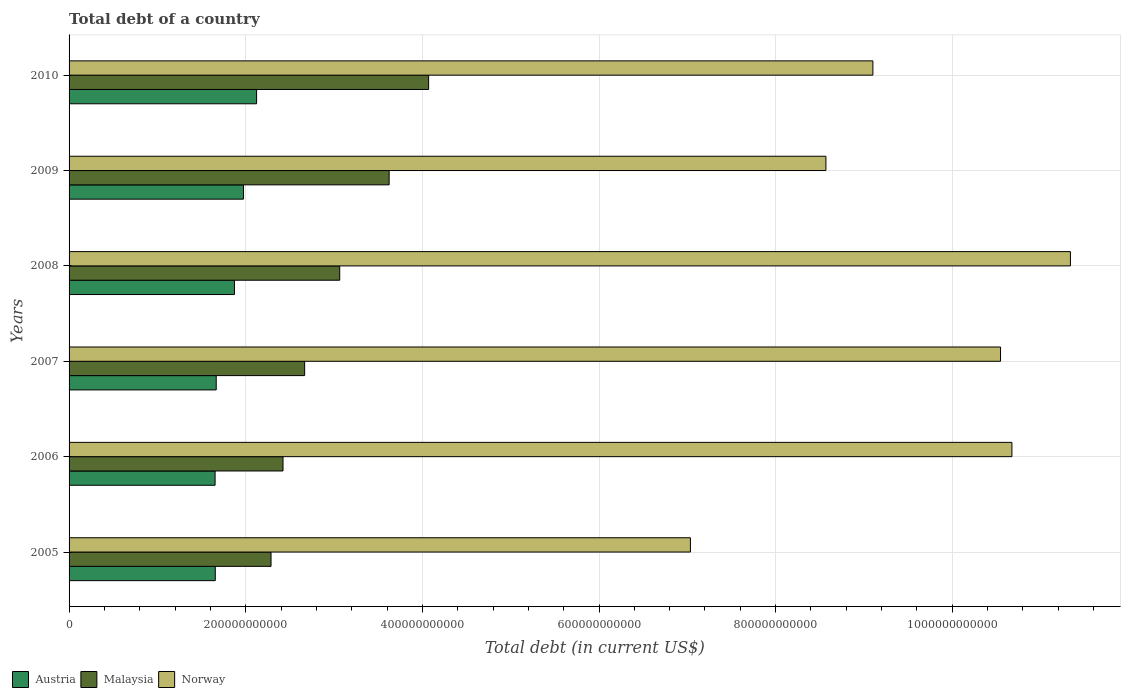How many different coloured bars are there?
Ensure brevity in your answer.  3. How many groups of bars are there?
Keep it short and to the point. 6. Are the number of bars per tick equal to the number of legend labels?
Offer a terse response. Yes. In how many cases, is the number of bars for a given year not equal to the number of legend labels?
Offer a terse response. 0. What is the debt in Norway in 2010?
Provide a succinct answer. 9.10e+11. Across all years, what is the maximum debt in Norway?
Your response must be concise. 1.13e+12. Across all years, what is the minimum debt in Austria?
Provide a short and direct response. 1.65e+11. In which year was the debt in Malaysia maximum?
Your answer should be compact. 2010. What is the total debt in Norway in the graph?
Your answer should be very brief. 5.73e+12. What is the difference between the debt in Malaysia in 2005 and that in 2007?
Offer a terse response. -3.81e+1. What is the difference between the debt in Norway in 2010 and the debt in Malaysia in 2005?
Your answer should be compact. 6.81e+11. What is the average debt in Malaysia per year?
Make the answer very short. 3.02e+11. In the year 2010, what is the difference between the debt in Austria and debt in Malaysia?
Offer a terse response. -1.95e+11. In how many years, is the debt in Malaysia greater than 880000000000 US$?
Keep it short and to the point. 0. What is the ratio of the debt in Malaysia in 2006 to that in 2010?
Your response must be concise. 0.59. What is the difference between the highest and the second highest debt in Malaysia?
Keep it short and to the point. 4.47e+1. What is the difference between the highest and the lowest debt in Austria?
Provide a short and direct response. 4.70e+1. In how many years, is the debt in Norway greater than the average debt in Norway taken over all years?
Provide a short and direct response. 3. Is the sum of the debt in Norway in 2005 and 2009 greater than the maximum debt in Malaysia across all years?
Your answer should be compact. Yes. What does the 1st bar from the top in 2010 represents?
Offer a terse response. Norway. What does the 2nd bar from the bottom in 2008 represents?
Your answer should be compact. Malaysia. Is it the case that in every year, the sum of the debt in Malaysia and debt in Austria is greater than the debt in Norway?
Your answer should be very brief. No. Are all the bars in the graph horizontal?
Ensure brevity in your answer.  Yes. How many years are there in the graph?
Offer a very short reply. 6. What is the difference between two consecutive major ticks on the X-axis?
Keep it short and to the point. 2.00e+11. What is the title of the graph?
Offer a very short reply. Total debt of a country. What is the label or title of the X-axis?
Your response must be concise. Total debt (in current US$). What is the Total debt (in current US$) in Austria in 2005?
Make the answer very short. 1.66e+11. What is the Total debt (in current US$) of Malaysia in 2005?
Your answer should be compact. 2.29e+11. What is the Total debt (in current US$) in Norway in 2005?
Your answer should be very brief. 7.04e+11. What is the Total debt (in current US$) of Austria in 2006?
Your response must be concise. 1.65e+11. What is the Total debt (in current US$) of Malaysia in 2006?
Provide a succinct answer. 2.42e+11. What is the Total debt (in current US$) in Norway in 2006?
Provide a short and direct response. 1.07e+12. What is the Total debt (in current US$) in Austria in 2007?
Give a very brief answer. 1.67e+11. What is the Total debt (in current US$) of Malaysia in 2007?
Your response must be concise. 2.67e+11. What is the Total debt (in current US$) of Norway in 2007?
Offer a very short reply. 1.05e+12. What is the Total debt (in current US$) of Austria in 2008?
Offer a very short reply. 1.87e+11. What is the Total debt (in current US$) of Malaysia in 2008?
Your answer should be compact. 3.06e+11. What is the Total debt (in current US$) of Norway in 2008?
Provide a short and direct response. 1.13e+12. What is the Total debt (in current US$) of Austria in 2009?
Provide a succinct answer. 1.97e+11. What is the Total debt (in current US$) in Malaysia in 2009?
Keep it short and to the point. 3.62e+11. What is the Total debt (in current US$) of Norway in 2009?
Provide a short and direct response. 8.57e+11. What is the Total debt (in current US$) in Austria in 2010?
Offer a terse response. 2.12e+11. What is the Total debt (in current US$) in Malaysia in 2010?
Give a very brief answer. 4.07e+11. What is the Total debt (in current US$) of Norway in 2010?
Ensure brevity in your answer.  9.10e+11. Across all years, what is the maximum Total debt (in current US$) in Austria?
Provide a succinct answer. 2.12e+11. Across all years, what is the maximum Total debt (in current US$) of Malaysia?
Keep it short and to the point. 4.07e+11. Across all years, what is the maximum Total debt (in current US$) in Norway?
Keep it short and to the point. 1.13e+12. Across all years, what is the minimum Total debt (in current US$) in Austria?
Offer a terse response. 1.65e+11. Across all years, what is the minimum Total debt (in current US$) in Malaysia?
Your answer should be very brief. 2.29e+11. Across all years, what is the minimum Total debt (in current US$) in Norway?
Offer a terse response. 7.04e+11. What is the total Total debt (in current US$) of Austria in the graph?
Make the answer very short. 1.09e+12. What is the total Total debt (in current US$) in Malaysia in the graph?
Offer a very short reply. 1.81e+12. What is the total Total debt (in current US$) of Norway in the graph?
Provide a succinct answer. 5.73e+12. What is the difference between the Total debt (in current US$) in Austria in 2005 and that in 2006?
Your response must be concise. 2.14e+08. What is the difference between the Total debt (in current US$) in Malaysia in 2005 and that in 2006?
Give a very brief answer. -1.36e+1. What is the difference between the Total debt (in current US$) in Norway in 2005 and that in 2006?
Your answer should be very brief. -3.64e+11. What is the difference between the Total debt (in current US$) in Austria in 2005 and that in 2007?
Make the answer very short. -1.07e+09. What is the difference between the Total debt (in current US$) in Malaysia in 2005 and that in 2007?
Offer a terse response. -3.81e+1. What is the difference between the Total debt (in current US$) in Norway in 2005 and that in 2007?
Ensure brevity in your answer.  -3.51e+11. What is the difference between the Total debt (in current US$) in Austria in 2005 and that in 2008?
Ensure brevity in your answer.  -2.17e+1. What is the difference between the Total debt (in current US$) in Malaysia in 2005 and that in 2008?
Provide a succinct answer. -7.78e+1. What is the difference between the Total debt (in current US$) in Norway in 2005 and that in 2008?
Keep it short and to the point. -4.30e+11. What is the difference between the Total debt (in current US$) in Austria in 2005 and that in 2009?
Your response must be concise. -3.19e+1. What is the difference between the Total debt (in current US$) in Malaysia in 2005 and that in 2009?
Your response must be concise. -1.34e+11. What is the difference between the Total debt (in current US$) of Norway in 2005 and that in 2009?
Keep it short and to the point. -1.53e+11. What is the difference between the Total debt (in current US$) in Austria in 2005 and that in 2010?
Keep it short and to the point. -4.68e+1. What is the difference between the Total debt (in current US$) of Malaysia in 2005 and that in 2010?
Provide a succinct answer. -1.78e+11. What is the difference between the Total debt (in current US$) of Norway in 2005 and that in 2010?
Your answer should be compact. -2.07e+11. What is the difference between the Total debt (in current US$) of Austria in 2006 and that in 2007?
Keep it short and to the point. -1.28e+09. What is the difference between the Total debt (in current US$) of Malaysia in 2006 and that in 2007?
Your answer should be very brief. -2.45e+1. What is the difference between the Total debt (in current US$) of Norway in 2006 and that in 2007?
Your answer should be compact. 1.29e+1. What is the difference between the Total debt (in current US$) of Austria in 2006 and that in 2008?
Provide a succinct answer. -2.19e+1. What is the difference between the Total debt (in current US$) in Malaysia in 2006 and that in 2008?
Provide a short and direct response. -6.42e+1. What is the difference between the Total debt (in current US$) in Norway in 2006 and that in 2008?
Offer a very short reply. -6.62e+1. What is the difference between the Total debt (in current US$) in Austria in 2006 and that in 2009?
Provide a succinct answer. -3.21e+1. What is the difference between the Total debt (in current US$) in Malaysia in 2006 and that in 2009?
Your answer should be compact. -1.20e+11. What is the difference between the Total debt (in current US$) in Norway in 2006 and that in 2009?
Make the answer very short. 2.11e+11. What is the difference between the Total debt (in current US$) in Austria in 2006 and that in 2010?
Make the answer very short. -4.70e+1. What is the difference between the Total debt (in current US$) of Malaysia in 2006 and that in 2010?
Make the answer very short. -1.65e+11. What is the difference between the Total debt (in current US$) in Norway in 2006 and that in 2010?
Offer a very short reply. 1.57e+11. What is the difference between the Total debt (in current US$) of Austria in 2007 and that in 2008?
Provide a short and direct response. -2.06e+1. What is the difference between the Total debt (in current US$) of Malaysia in 2007 and that in 2008?
Your response must be concise. -3.97e+1. What is the difference between the Total debt (in current US$) of Norway in 2007 and that in 2008?
Ensure brevity in your answer.  -7.91e+1. What is the difference between the Total debt (in current US$) of Austria in 2007 and that in 2009?
Make the answer very short. -3.08e+1. What is the difference between the Total debt (in current US$) in Malaysia in 2007 and that in 2009?
Offer a very short reply. -9.57e+1. What is the difference between the Total debt (in current US$) in Norway in 2007 and that in 2009?
Keep it short and to the point. 1.98e+11. What is the difference between the Total debt (in current US$) in Austria in 2007 and that in 2010?
Provide a succinct answer. -4.57e+1. What is the difference between the Total debt (in current US$) of Malaysia in 2007 and that in 2010?
Your answer should be compact. -1.40e+11. What is the difference between the Total debt (in current US$) in Norway in 2007 and that in 2010?
Provide a short and direct response. 1.45e+11. What is the difference between the Total debt (in current US$) of Austria in 2008 and that in 2009?
Your response must be concise. -1.02e+1. What is the difference between the Total debt (in current US$) of Malaysia in 2008 and that in 2009?
Ensure brevity in your answer.  -5.59e+1. What is the difference between the Total debt (in current US$) in Norway in 2008 and that in 2009?
Make the answer very short. 2.77e+11. What is the difference between the Total debt (in current US$) in Austria in 2008 and that in 2010?
Keep it short and to the point. -2.51e+1. What is the difference between the Total debt (in current US$) in Malaysia in 2008 and that in 2010?
Offer a very short reply. -1.01e+11. What is the difference between the Total debt (in current US$) of Norway in 2008 and that in 2010?
Make the answer very short. 2.24e+11. What is the difference between the Total debt (in current US$) of Austria in 2009 and that in 2010?
Your response must be concise. -1.49e+1. What is the difference between the Total debt (in current US$) in Malaysia in 2009 and that in 2010?
Make the answer very short. -4.47e+1. What is the difference between the Total debt (in current US$) of Norway in 2009 and that in 2010?
Provide a short and direct response. -5.32e+1. What is the difference between the Total debt (in current US$) in Austria in 2005 and the Total debt (in current US$) in Malaysia in 2006?
Your answer should be very brief. -7.67e+1. What is the difference between the Total debt (in current US$) of Austria in 2005 and the Total debt (in current US$) of Norway in 2006?
Offer a very short reply. -9.02e+11. What is the difference between the Total debt (in current US$) of Malaysia in 2005 and the Total debt (in current US$) of Norway in 2006?
Make the answer very short. -8.39e+11. What is the difference between the Total debt (in current US$) in Austria in 2005 and the Total debt (in current US$) in Malaysia in 2007?
Offer a very short reply. -1.01e+11. What is the difference between the Total debt (in current US$) of Austria in 2005 and the Total debt (in current US$) of Norway in 2007?
Provide a short and direct response. -8.89e+11. What is the difference between the Total debt (in current US$) in Malaysia in 2005 and the Total debt (in current US$) in Norway in 2007?
Offer a very short reply. -8.26e+11. What is the difference between the Total debt (in current US$) of Austria in 2005 and the Total debt (in current US$) of Malaysia in 2008?
Keep it short and to the point. -1.41e+11. What is the difference between the Total debt (in current US$) of Austria in 2005 and the Total debt (in current US$) of Norway in 2008?
Provide a succinct answer. -9.68e+11. What is the difference between the Total debt (in current US$) in Malaysia in 2005 and the Total debt (in current US$) in Norway in 2008?
Your answer should be compact. -9.05e+11. What is the difference between the Total debt (in current US$) of Austria in 2005 and the Total debt (in current US$) of Malaysia in 2009?
Offer a terse response. -1.97e+11. What is the difference between the Total debt (in current US$) of Austria in 2005 and the Total debt (in current US$) of Norway in 2009?
Make the answer very short. -6.91e+11. What is the difference between the Total debt (in current US$) of Malaysia in 2005 and the Total debt (in current US$) of Norway in 2009?
Your answer should be very brief. -6.28e+11. What is the difference between the Total debt (in current US$) in Austria in 2005 and the Total debt (in current US$) in Malaysia in 2010?
Your answer should be compact. -2.42e+11. What is the difference between the Total debt (in current US$) in Austria in 2005 and the Total debt (in current US$) in Norway in 2010?
Your answer should be very brief. -7.45e+11. What is the difference between the Total debt (in current US$) in Malaysia in 2005 and the Total debt (in current US$) in Norway in 2010?
Your answer should be compact. -6.81e+11. What is the difference between the Total debt (in current US$) in Austria in 2006 and the Total debt (in current US$) in Malaysia in 2007?
Your answer should be compact. -1.01e+11. What is the difference between the Total debt (in current US$) of Austria in 2006 and the Total debt (in current US$) of Norway in 2007?
Your answer should be compact. -8.89e+11. What is the difference between the Total debt (in current US$) in Malaysia in 2006 and the Total debt (in current US$) in Norway in 2007?
Make the answer very short. -8.12e+11. What is the difference between the Total debt (in current US$) of Austria in 2006 and the Total debt (in current US$) of Malaysia in 2008?
Ensure brevity in your answer.  -1.41e+11. What is the difference between the Total debt (in current US$) in Austria in 2006 and the Total debt (in current US$) in Norway in 2008?
Make the answer very short. -9.68e+11. What is the difference between the Total debt (in current US$) of Malaysia in 2006 and the Total debt (in current US$) of Norway in 2008?
Your answer should be compact. -8.92e+11. What is the difference between the Total debt (in current US$) in Austria in 2006 and the Total debt (in current US$) in Malaysia in 2009?
Give a very brief answer. -1.97e+11. What is the difference between the Total debt (in current US$) of Austria in 2006 and the Total debt (in current US$) of Norway in 2009?
Keep it short and to the point. -6.92e+11. What is the difference between the Total debt (in current US$) of Malaysia in 2006 and the Total debt (in current US$) of Norway in 2009?
Offer a very short reply. -6.15e+11. What is the difference between the Total debt (in current US$) of Austria in 2006 and the Total debt (in current US$) of Malaysia in 2010?
Give a very brief answer. -2.42e+11. What is the difference between the Total debt (in current US$) of Austria in 2006 and the Total debt (in current US$) of Norway in 2010?
Your answer should be compact. -7.45e+11. What is the difference between the Total debt (in current US$) in Malaysia in 2006 and the Total debt (in current US$) in Norway in 2010?
Make the answer very short. -6.68e+11. What is the difference between the Total debt (in current US$) in Austria in 2007 and the Total debt (in current US$) in Malaysia in 2008?
Give a very brief answer. -1.40e+11. What is the difference between the Total debt (in current US$) in Austria in 2007 and the Total debt (in current US$) in Norway in 2008?
Give a very brief answer. -9.67e+11. What is the difference between the Total debt (in current US$) of Malaysia in 2007 and the Total debt (in current US$) of Norway in 2008?
Give a very brief answer. -8.67e+11. What is the difference between the Total debt (in current US$) in Austria in 2007 and the Total debt (in current US$) in Malaysia in 2009?
Provide a short and direct response. -1.96e+11. What is the difference between the Total debt (in current US$) in Austria in 2007 and the Total debt (in current US$) in Norway in 2009?
Offer a terse response. -6.90e+11. What is the difference between the Total debt (in current US$) of Malaysia in 2007 and the Total debt (in current US$) of Norway in 2009?
Ensure brevity in your answer.  -5.90e+11. What is the difference between the Total debt (in current US$) in Austria in 2007 and the Total debt (in current US$) in Malaysia in 2010?
Ensure brevity in your answer.  -2.40e+11. What is the difference between the Total debt (in current US$) of Austria in 2007 and the Total debt (in current US$) of Norway in 2010?
Offer a very short reply. -7.43e+11. What is the difference between the Total debt (in current US$) of Malaysia in 2007 and the Total debt (in current US$) of Norway in 2010?
Provide a short and direct response. -6.43e+11. What is the difference between the Total debt (in current US$) in Austria in 2008 and the Total debt (in current US$) in Malaysia in 2009?
Offer a very short reply. -1.75e+11. What is the difference between the Total debt (in current US$) of Austria in 2008 and the Total debt (in current US$) of Norway in 2009?
Your answer should be very brief. -6.70e+11. What is the difference between the Total debt (in current US$) of Malaysia in 2008 and the Total debt (in current US$) of Norway in 2009?
Make the answer very short. -5.50e+11. What is the difference between the Total debt (in current US$) of Austria in 2008 and the Total debt (in current US$) of Malaysia in 2010?
Ensure brevity in your answer.  -2.20e+11. What is the difference between the Total debt (in current US$) in Austria in 2008 and the Total debt (in current US$) in Norway in 2010?
Provide a short and direct response. -7.23e+11. What is the difference between the Total debt (in current US$) in Malaysia in 2008 and the Total debt (in current US$) in Norway in 2010?
Your answer should be very brief. -6.04e+11. What is the difference between the Total debt (in current US$) in Austria in 2009 and the Total debt (in current US$) in Malaysia in 2010?
Offer a very short reply. -2.10e+11. What is the difference between the Total debt (in current US$) in Austria in 2009 and the Total debt (in current US$) in Norway in 2010?
Offer a very short reply. -7.13e+11. What is the difference between the Total debt (in current US$) of Malaysia in 2009 and the Total debt (in current US$) of Norway in 2010?
Your response must be concise. -5.48e+11. What is the average Total debt (in current US$) in Austria per year?
Ensure brevity in your answer.  1.82e+11. What is the average Total debt (in current US$) in Malaysia per year?
Your answer should be very brief. 3.02e+11. What is the average Total debt (in current US$) of Norway per year?
Your answer should be compact. 9.54e+11. In the year 2005, what is the difference between the Total debt (in current US$) of Austria and Total debt (in current US$) of Malaysia?
Make the answer very short. -6.31e+1. In the year 2005, what is the difference between the Total debt (in current US$) in Austria and Total debt (in current US$) in Norway?
Offer a terse response. -5.38e+11. In the year 2005, what is the difference between the Total debt (in current US$) in Malaysia and Total debt (in current US$) in Norway?
Make the answer very short. -4.75e+11. In the year 2006, what is the difference between the Total debt (in current US$) of Austria and Total debt (in current US$) of Malaysia?
Make the answer very short. -7.69e+1. In the year 2006, what is the difference between the Total debt (in current US$) of Austria and Total debt (in current US$) of Norway?
Make the answer very short. -9.02e+11. In the year 2006, what is the difference between the Total debt (in current US$) in Malaysia and Total debt (in current US$) in Norway?
Offer a terse response. -8.25e+11. In the year 2007, what is the difference between the Total debt (in current US$) of Austria and Total debt (in current US$) of Malaysia?
Give a very brief answer. -1.00e+11. In the year 2007, what is the difference between the Total debt (in current US$) of Austria and Total debt (in current US$) of Norway?
Your response must be concise. -8.88e+11. In the year 2007, what is the difference between the Total debt (in current US$) in Malaysia and Total debt (in current US$) in Norway?
Offer a very short reply. -7.88e+11. In the year 2008, what is the difference between the Total debt (in current US$) of Austria and Total debt (in current US$) of Malaysia?
Give a very brief answer. -1.19e+11. In the year 2008, what is the difference between the Total debt (in current US$) in Austria and Total debt (in current US$) in Norway?
Ensure brevity in your answer.  -9.46e+11. In the year 2008, what is the difference between the Total debt (in current US$) of Malaysia and Total debt (in current US$) of Norway?
Offer a very short reply. -8.27e+11. In the year 2009, what is the difference between the Total debt (in current US$) in Austria and Total debt (in current US$) in Malaysia?
Provide a succinct answer. -1.65e+11. In the year 2009, what is the difference between the Total debt (in current US$) of Austria and Total debt (in current US$) of Norway?
Provide a succinct answer. -6.59e+11. In the year 2009, what is the difference between the Total debt (in current US$) in Malaysia and Total debt (in current US$) in Norway?
Make the answer very short. -4.95e+11. In the year 2010, what is the difference between the Total debt (in current US$) in Austria and Total debt (in current US$) in Malaysia?
Give a very brief answer. -1.95e+11. In the year 2010, what is the difference between the Total debt (in current US$) in Austria and Total debt (in current US$) in Norway?
Your response must be concise. -6.98e+11. In the year 2010, what is the difference between the Total debt (in current US$) of Malaysia and Total debt (in current US$) of Norway?
Give a very brief answer. -5.03e+11. What is the ratio of the Total debt (in current US$) in Malaysia in 2005 to that in 2006?
Provide a succinct answer. 0.94. What is the ratio of the Total debt (in current US$) of Norway in 2005 to that in 2006?
Ensure brevity in your answer.  0.66. What is the ratio of the Total debt (in current US$) in Malaysia in 2005 to that in 2007?
Ensure brevity in your answer.  0.86. What is the ratio of the Total debt (in current US$) in Norway in 2005 to that in 2007?
Offer a very short reply. 0.67. What is the ratio of the Total debt (in current US$) in Austria in 2005 to that in 2008?
Provide a short and direct response. 0.88. What is the ratio of the Total debt (in current US$) of Malaysia in 2005 to that in 2008?
Your answer should be compact. 0.75. What is the ratio of the Total debt (in current US$) of Norway in 2005 to that in 2008?
Offer a terse response. 0.62. What is the ratio of the Total debt (in current US$) of Austria in 2005 to that in 2009?
Make the answer very short. 0.84. What is the ratio of the Total debt (in current US$) in Malaysia in 2005 to that in 2009?
Your answer should be very brief. 0.63. What is the ratio of the Total debt (in current US$) in Norway in 2005 to that in 2009?
Give a very brief answer. 0.82. What is the ratio of the Total debt (in current US$) in Austria in 2005 to that in 2010?
Offer a very short reply. 0.78. What is the ratio of the Total debt (in current US$) of Malaysia in 2005 to that in 2010?
Your answer should be compact. 0.56. What is the ratio of the Total debt (in current US$) in Norway in 2005 to that in 2010?
Your response must be concise. 0.77. What is the ratio of the Total debt (in current US$) of Austria in 2006 to that in 2007?
Your answer should be compact. 0.99. What is the ratio of the Total debt (in current US$) of Malaysia in 2006 to that in 2007?
Keep it short and to the point. 0.91. What is the ratio of the Total debt (in current US$) in Norway in 2006 to that in 2007?
Offer a terse response. 1.01. What is the ratio of the Total debt (in current US$) of Austria in 2006 to that in 2008?
Provide a succinct answer. 0.88. What is the ratio of the Total debt (in current US$) in Malaysia in 2006 to that in 2008?
Your response must be concise. 0.79. What is the ratio of the Total debt (in current US$) in Norway in 2006 to that in 2008?
Offer a very short reply. 0.94. What is the ratio of the Total debt (in current US$) of Austria in 2006 to that in 2009?
Ensure brevity in your answer.  0.84. What is the ratio of the Total debt (in current US$) of Malaysia in 2006 to that in 2009?
Your answer should be compact. 0.67. What is the ratio of the Total debt (in current US$) of Norway in 2006 to that in 2009?
Your answer should be very brief. 1.25. What is the ratio of the Total debt (in current US$) in Austria in 2006 to that in 2010?
Your answer should be very brief. 0.78. What is the ratio of the Total debt (in current US$) in Malaysia in 2006 to that in 2010?
Provide a short and direct response. 0.59. What is the ratio of the Total debt (in current US$) in Norway in 2006 to that in 2010?
Make the answer very short. 1.17. What is the ratio of the Total debt (in current US$) in Austria in 2007 to that in 2008?
Your response must be concise. 0.89. What is the ratio of the Total debt (in current US$) in Malaysia in 2007 to that in 2008?
Keep it short and to the point. 0.87. What is the ratio of the Total debt (in current US$) of Norway in 2007 to that in 2008?
Your response must be concise. 0.93. What is the ratio of the Total debt (in current US$) in Austria in 2007 to that in 2009?
Provide a short and direct response. 0.84. What is the ratio of the Total debt (in current US$) in Malaysia in 2007 to that in 2009?
Your response must be concise. 0.74. What is the ratio of the Total debt (in current US$) in Norway in 2007 to that in 2009?
Offer a terse response. 1.23. What is the ratio of the Total debt (in current US$) in Austria in 2007 to that in 2010?
Your answer should be compact. 0.78. What is the ratio of the Total debt (in current US$) of Malaysia in 2007 to that in 2010?
Give a very brief answer. 0.66. What is the ratio of the Total debt (in current US$) of Norway in 2007 to that in 2010?
Provide a short and direct response. 1.16. What is the ratio of the Total debt (in current US$) in Austria in 2008 to that in 2009?
Keep it short and to the point. 0.95. What is the ratio of the Total debt (in current US$) of Malaysia in 2008 to that in 2009?
Give a very brief answer. 0.85. What is the ratio of the Total debt (in current US$) in Norway in 2008 to that in 2009?
Give a very brief answer. 1.32. What is the ratio of the Total debt (in current US$) of Austria in 2008 to that in 2010?
Keep it short and to the point. 0.88. What is the ratio of the Total debt (in current US$) in Malaysia in 2008 to that in 2010?
Keep it short and to the point. 0.75. What is the ratio of the Total debt (in current US$) of Norway in 2008 to that in 2010?
Your answer should be very brief. 1.25. What is the ratio of the Total debt (in current US$) in Malaysia in 2009 to that in 2010?
Your response must be concise. 0.89. What is the ratio of the Total debt (in current US$) of Norway in 2009 to that in 2010?
Your response must be concise. 0.94. What is the difference between the highest and the second highest Total debt (in current US$) in Austria?
Keep it short and to the point. 1.49e+1. What is the difference between the highest and the second highest Total debt (in current US$) in Malaysia?
Your response must be concise. 4.47e+1. What is the difference between the highest and the second highest Total debt (in current US$) in Norway?
Offer a terse response. 6.62e+1. What is the difference between the highest and the lowest Total debt (in current US$) in Austria?
Offer a very short reply. 4.70e+1. What is the difference between the highest and the lowest Total debt (in current US$) of Malaysia?
Give a very brief answer. 1.78e+11. What is the difference between the highest and the lowest Total debt (in current US$) of Norway?
Ensure brevity in your answer.  4.30e+11. 